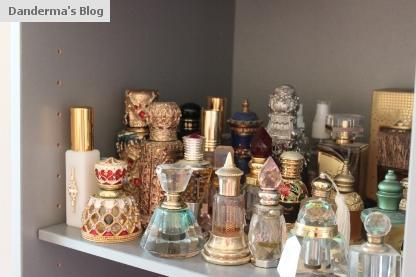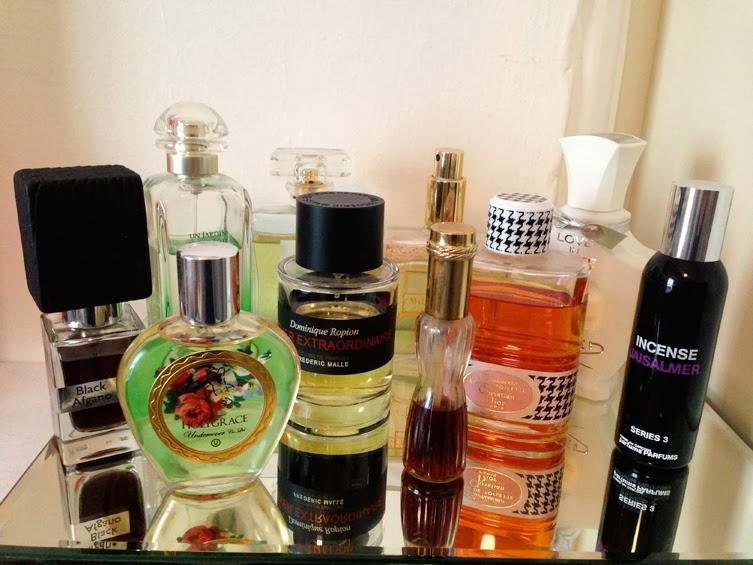The first image is the image on the left, the second image is the image on the right. For the images displayed, is the sentence "A heart-shaped clear glass bottle is in the front of a grouping of different fragrance bottles." factually correct? Answer yes or no. No. 